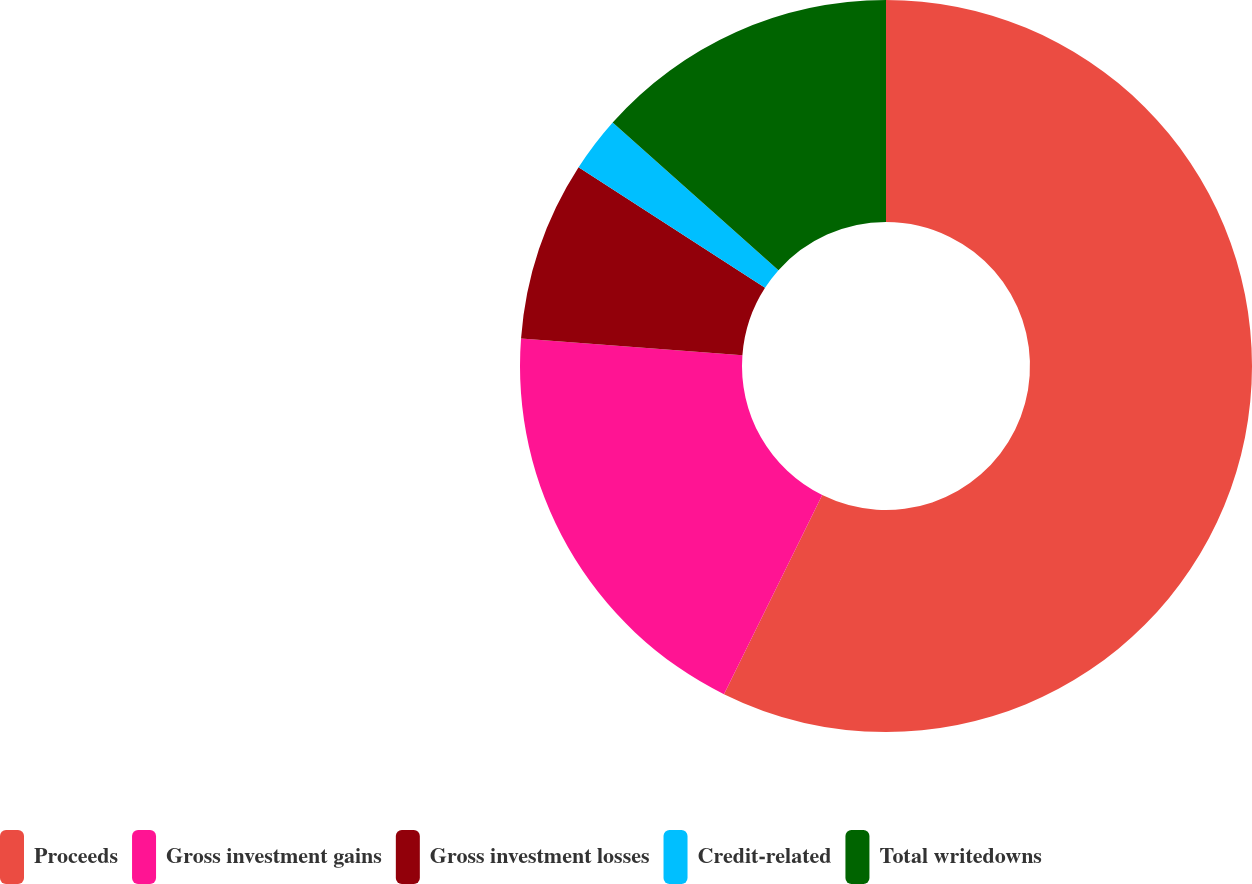<chart> <loc_0><loc_0><loc_500><loc_500><pie_chart><fcel>Proceeds<fcel>Gross investment gains<fcel>Gross investment losses<fcel>Credit-related<fcel>Total writedowns<nl><fcel>57.3%<fcel>18.9%<fcel>7.93%<fcel>2.45%<fcel>13.42%<nl></chart> 